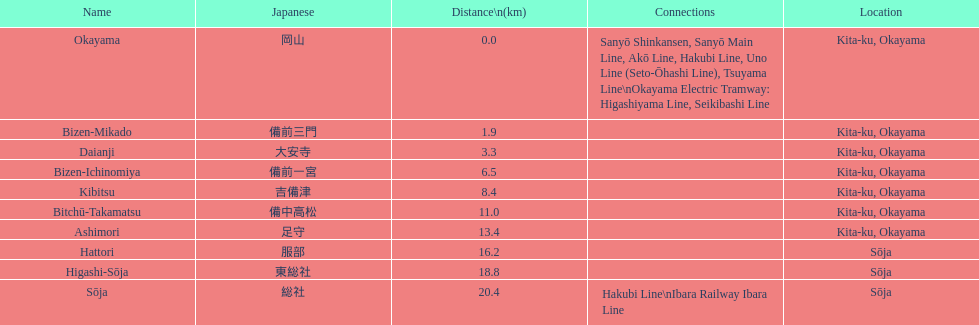How many successive stops do you need to pass if you get on the kibi line at bizen-mikado and leave at kibitsu? 2. 